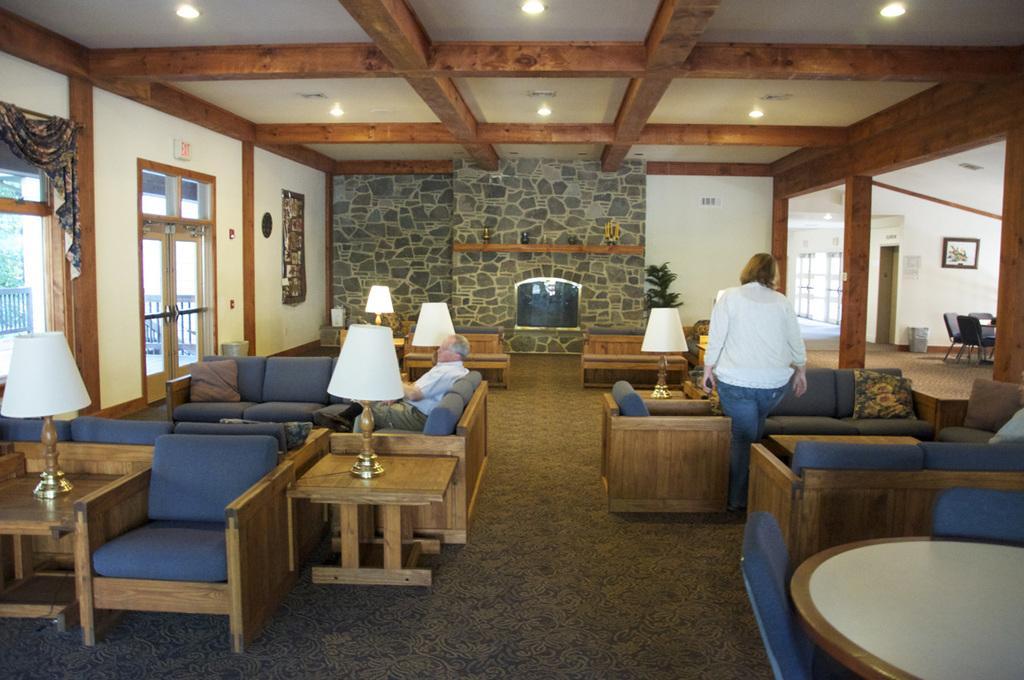Could you give a brief overview of what you see in this image? This picture is a woman standing here there is a set of sofa here with some pillows, and on the left side there is another man sitting on the left there also a sofa and lamp and in the backdrop there is a wall. on the left I can see a door and windows, curtains and onto the ceiling we can see some lights. 